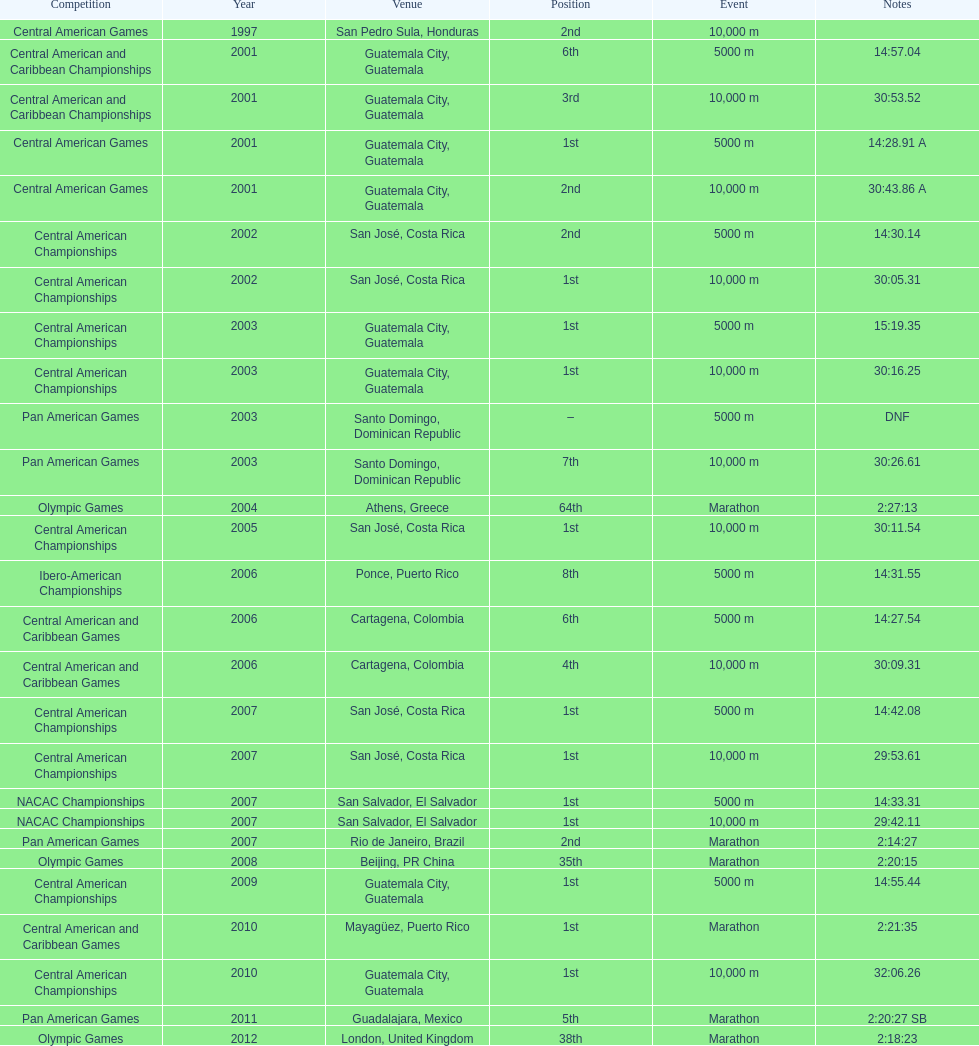Would you mind parsing the complete table? {'header': ['Competition', 'Year', 'Venue', 'Position', 'Event', 'Notes'], 'rows': [['Central American Games', '1997', 'San Pedro Sula, Honduras', '2nd', '10,000 m', ''], ['Central American and Caribbean Championships', '2001', 'Guatemala City, Guatemala', '6th', '5000 m', '14:57.04'], ['Central American and Caribbean Championships', '2001', 'Guatemala City, Guatemala', '3rd', '10,000 m', '30:53.52'], ['Central American Games', '2001', 'Guatemala City, Guatemala', '1st', '5000 m', '14:28.91 A'], ['Central American Games', '2001', 'Guatemala City, Guatemala', '2nd', '10,000 m', '30:43.86 A'], ['Central American Championships', '2002', 'San José, Costa Rica', '2nd', '5000 m', '14:30.14'], ['Central American Championships', '2002', 'San José, Costa Rica', '1st', '10,000 m', '30:05.31'], ['Central American Championships', '2003', 'Guatemala City, Guatemala', '1st', '5000 m', '15:19.35'], ['Central American Championships', '2003', 'Guatemala City, Guatemala', '1st', '10,000 m', '30:16.25'], ['Pan American Games', '2003', 'Santo Domingo, Dominican Republic', '–', '5000 m', 'DNF'], ['Pan American Games', '2003', 'Santo Domingo, Dominican Republic', '7th', '10,000 m', '30:26.61'], ['Olympic Games', '2004', 'Athens, Greece', '64th', 'Marathon', '2:27:13'], ['Central American Championships', '2005', 'San José, Costa Rica', '1st', '10,000 m', '30:11.54'], ['Ibero-American Championships', '2006', 'Ponce, Puerto Rico', '8th', '5000 m', '14:31.55'], ['Central American and Caribbean Games', '2006', 'Cartagena, Colombia', '6th', '5000 m', '14:27.54'], ['Central American and Caribbean Games', '2006', 'Cartagena, Colombia', '4th', '10,000 m', '30:09.31'], ['Central American Championships', '2007', 'San José, Costa Rica', '1st', '5000 m', '14:42.08'], ['Central American Championships', '2007', 'San José, Costa Rica', '1st', '10,000 m', '29:53.61'], ['NACAC Championships', '2007', 'San Salvador, El Salvador', '1st', '5000 m', '14:33.31'], ['NACAC Championships', '2007', 'San Salvador, El Salvador', '1st', '10,000 m', '29:42.11'], ['Pan American Games', '2007', 'Rio de Janeiro, Brazil', '2nd', 'Marathon', '2:14:27'], ['Olympic Games', '2008', 'Beijing, PR China', '35th', 'Marathon', '2:20:15'], ['Central American Championships', '2009', 'Guatemala City, Guatemala', '1st', '5000 m', '14:55.44'], ['Central American and Caribbean Games', '2010', 'Mayagüez, Puerto Rico', '1st', 'Marathon', '2:21:35'], ['Central American Championships', '2010', 'Guatemala City, Guatemala', '1st', '10,000 m', '32:06.26'], ['Pan American Games', '2011', 'Guadalajara, Mexico', '5th', 'Marathon', '2:20:27 SB'], ['Olympic Games', '2012', 'London, United Kingdom', '38th', 'Marathon', '2:18:23']]} Which of each game in 2007 was in the 2nd position? Pan American Games. 